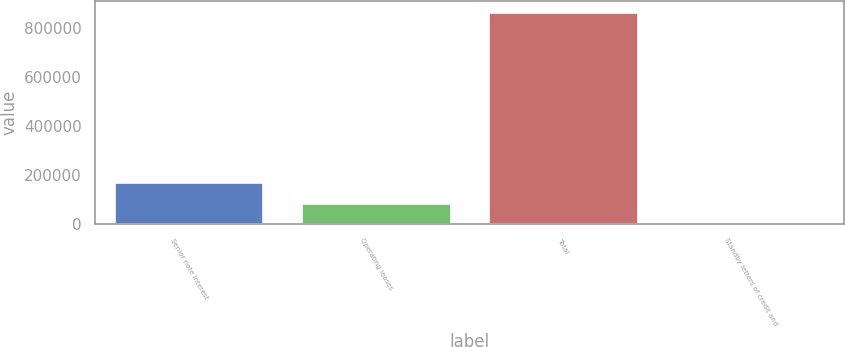Convert chart to OTSL. <chart><loc_0><loc_0><loc_500><loc_500><bar_chart><fcel>Senior note interest<fcel>Operating leases<fcel>Total<fcel>Standby letters of credit and<nl><fcel>173368<fcel>86740.3<fcel>866386<fcel>113<nl></chart> 